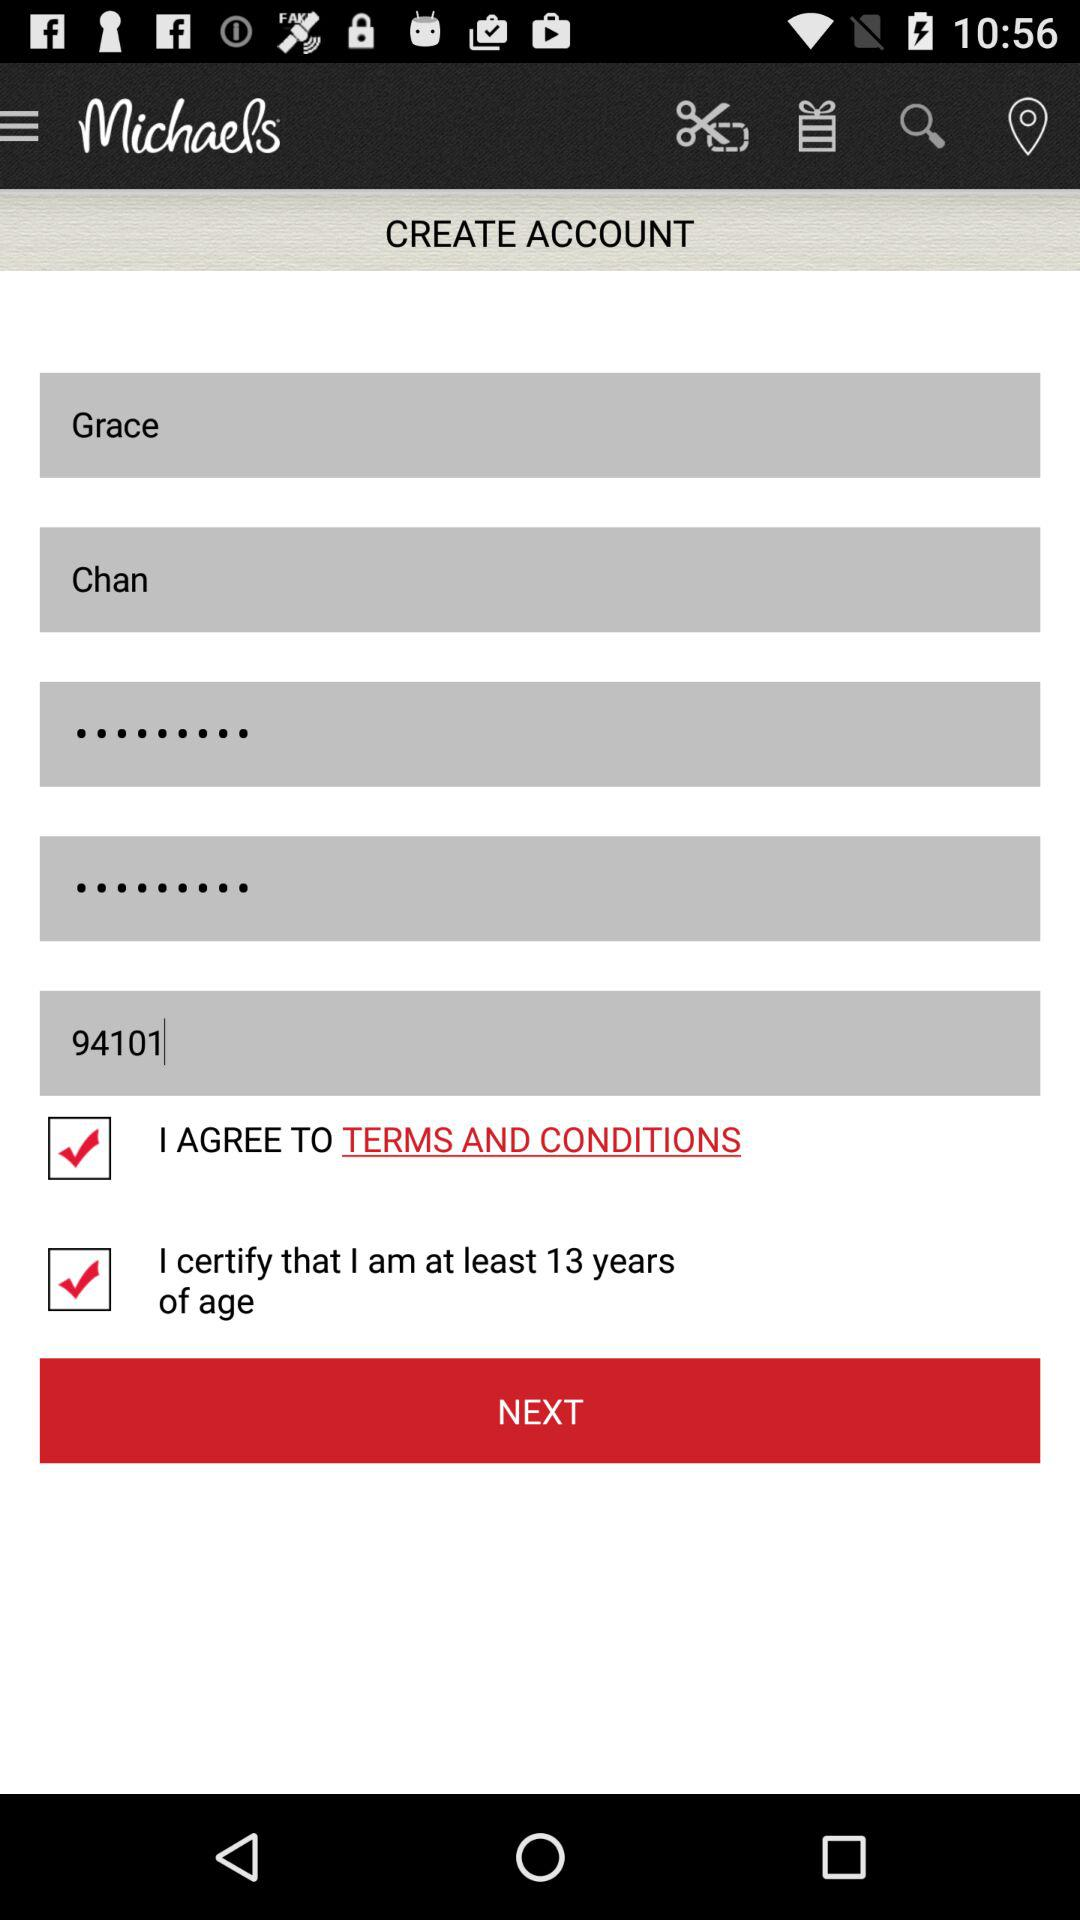What is the last name? The last name is Chan. 